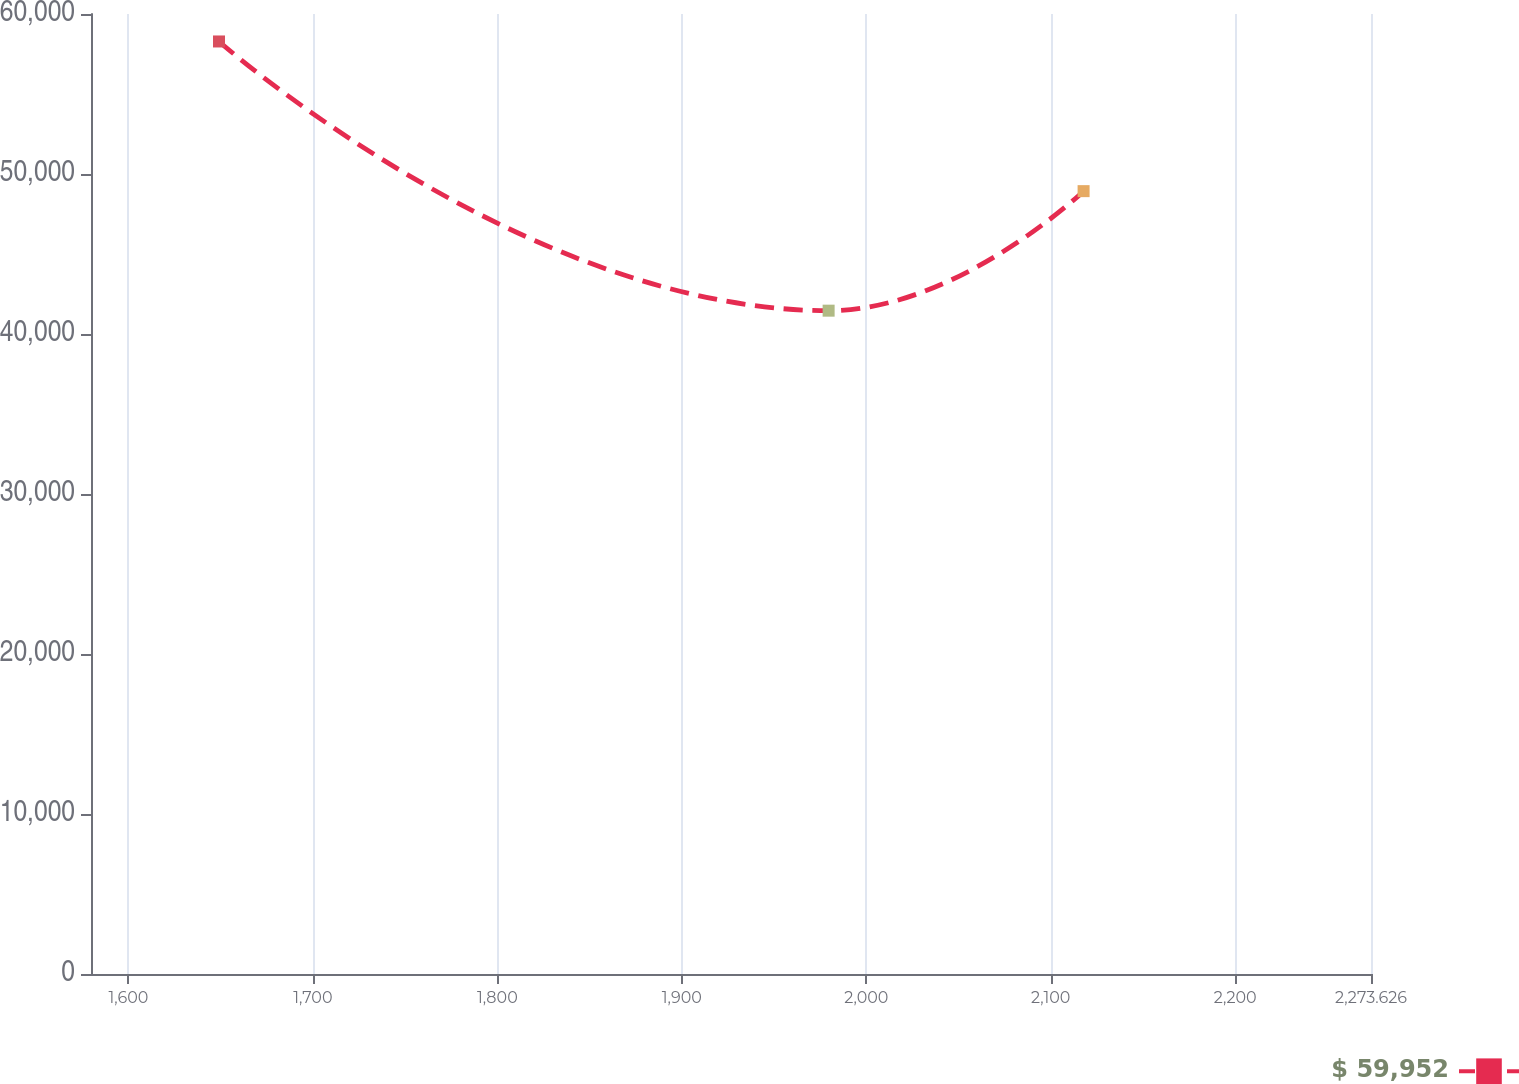<chart> <loc_0><loc_0><loc_500><loc_500><line_chart><ecel><fcel>$ 59,952<nl><fcel>1649.08<fcel>58283.2<nl><fcel>1979.58<fcel>41458.3<nl><fcel>2117.81<fcel>48928.9<nl><fcel>2343.02<fcel>33802.2<nl></chart> 